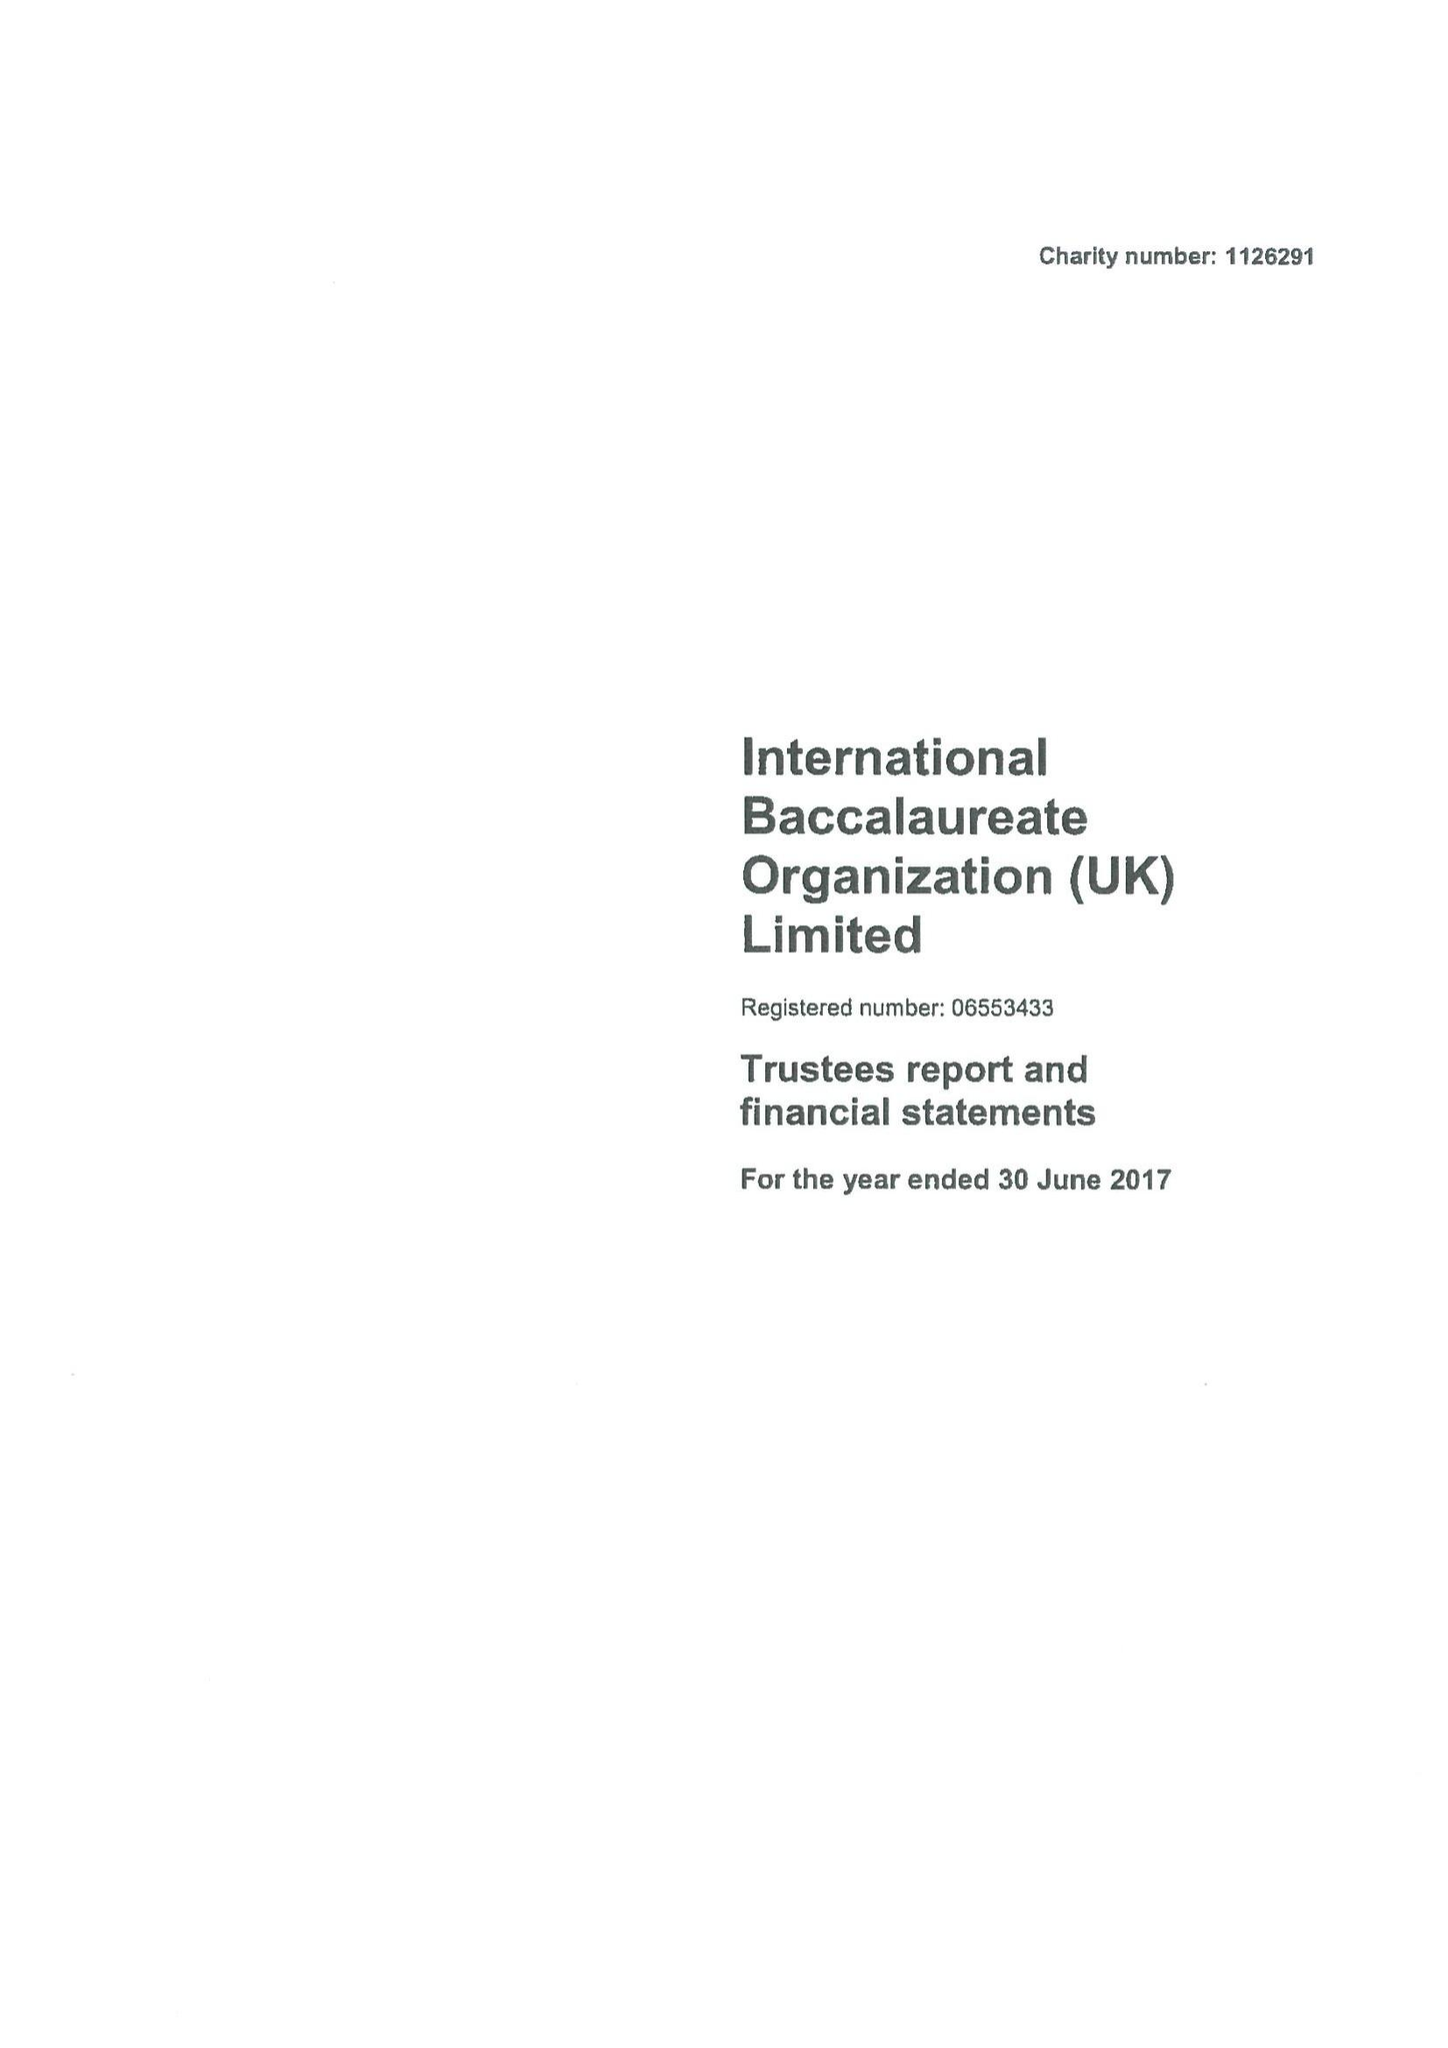What is the value for the charity_name?
Answer the question using a single word or phrase. International Baccalaureate Organization (Uk) Ltd. 